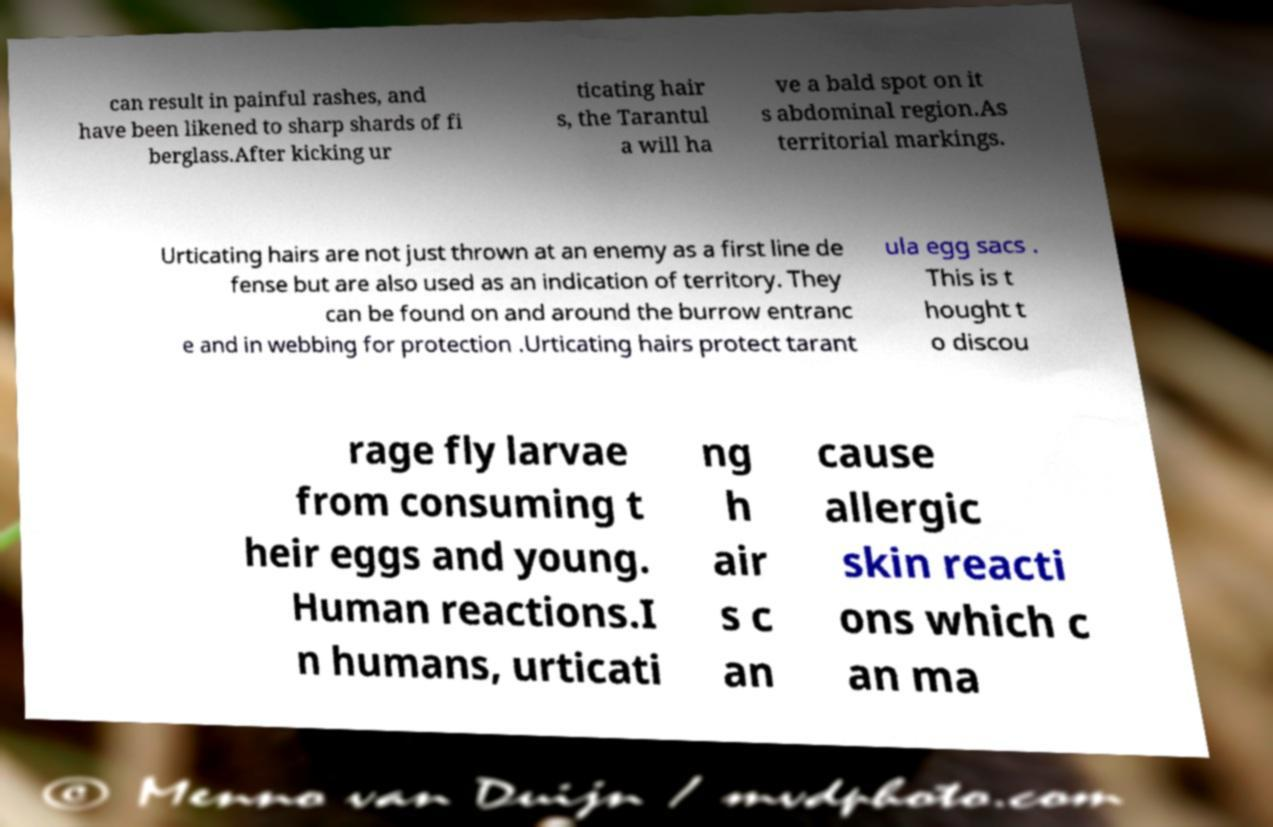There's text embedded in this image that I need extracted. Can you transcribe it verbatim? can result in painful rashes, and have been likened to sharp shards of fi berglass.After kicking ur ticating hair s, the Tarantul a will ha ve a bald spot on it s abdominal region.As territorial markings. Urticating hairs are not just thrown at an enemy as a first line de fense but are also used as an indication of territory. They can be found on and around the burrow entranc e and in webbing for protection .Urticating hairs protect tarant ula egg sacs . This is t hought t o discou rage fly larvae from consuming t heir eggs and young. Human reactions.I n humans, urticati ng h air s c an cause allergic skin reacti ons which c an ma 